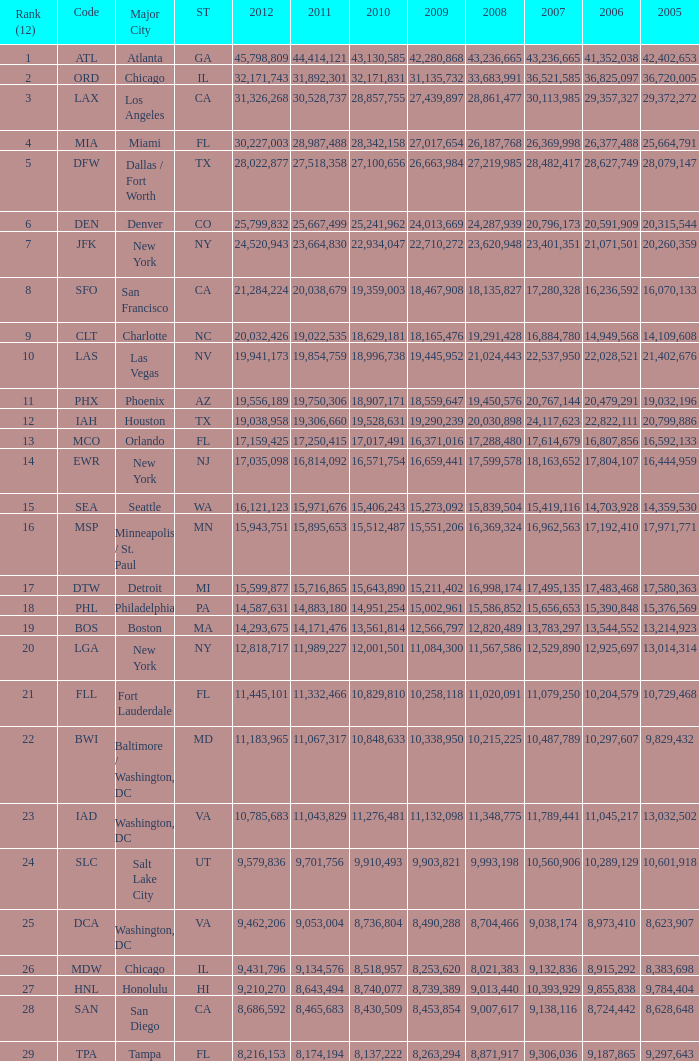Could you parse the entire table? {'header': ['Rank (12)', 'Code', 'Major City', 'ST', '2012', '2011', '2010', '2009', '2008', '2007', '2006', '2005'], 'rows': [['1', 'ATL', 'Atlanta', 'GA', '45,798,809', '44,414,121', '43,130,585', '42,280,868', '43,236,665', '43,236,665', '41,352,038', '42,402,653'], ['2', 'ORD', 'Chicago', 'IL', '32,171,743', '31,892,301', '32,171,831', '31,135,732', '33,683,991', '36,521,585', '36,825,097', '36,720,005'], ['3', 'LAX', 'Los Angeles', 'CA', '31,326,268', '30,528,737', '28,857,755', '27,439,897', '28,861,477', '30,113,985', '29,357,327', '29,372,272'], ['4', 'MIA', 'Miami', 'FL', '30,227,003', '28,987,488', '28,342,158', '27,017,654', '26,187,768', '26,369,998', '26,377,488', '25,664,791'], ['5', 'DFW', 'Dallas / Fort Worth', 'TX', '28,022,877', '27,518,358', '27,100,656', '26,663,984', '27,219,985', '28,482,417', '28,627,749', '28,079,147'], ['6', 'DEN', 'Denver', 'CO', '25,799,832', '25,667,499', '25,241,962', '24,013,669', '24,287,939', '20,796,173', '20,591,909', '20,315,544'], ['7', 'JFK', 'New York', 'NY', '24,520,943', '23,664,830', '22,934,047', '22,710,272', '23,620,948', '23,401,351', '21,071,501', '20,260,359'], ['8', 'SFO', 'San Francisco', 'CA', '21,284,224', '20,038,679', '19,359,003', '18,467,908', '18,135,827', '17,280,328', '16,236,592', '16,070,133'], ['9', 'CLT', 'Charlotte', 'NC', '20,032,426', '19,022,535', '18,629,181', '18,165,476', '19,291,428', '16,884,780', '14,949,568', '14,109,608'], ['10', 'LAS', 'Las Vegas', 'NV', '19,941,173', '19,854,759', '18,996,738', '19,445,952', '21,024,443', '22,537,950', '22,028,521', '21,402,676'], ['11', 'PHX', 'Phoenix', 'AZ', '19,556,189', '19,750,306', '18,907,171', '18,559,647', '19,450,576', '20,767,144', '20,479,291', '19,032,196'], ['12', 'IAH', 'Houston', 'TX', '19,038,958', '19,306,660', '19,528,631', '19,290,239', '20,030,898', '24,117,623', '22,822,111', '20,799,886'], ['13', 'MCO', 'Orlando', 'FL', '17,159,425', '17,250,415', '17,017,491', '16,371,016', '17,288,480', '17,614,679', '16,807,856', '16,592,133'], ['14', 'EWR', 'New York', 'NJ', '17,035,098', '16,814,092', '16,571,754', '16,659,441', '17,599,578', '18,163,652', '17,804,107', '16,444,959'], ['15', 'SEA', 'Seattle', 'WA', '16,121,123', '15,971,676', '15,406,243', '15,273,092', '15,839,504', '15,419,116', '14,703,928', '14,359,530'], ['16', 'MSP', 'Minneapolis / St. Paul', 'MN', '15,943,751', '15,895,653', '15,512,487', '15,551,206', '16,369,324', '16,962,563', '17,192,410', '17,971,771'], ['17', 'DTW', 'Detroit', 'MI', '15,599,877', '15,716,865', '15,643,890', '15,211,402', '16,998,174', '17,495,135', '17,483,468', '17,580,363'], ['18', 'PHL', 'Philadelphia', 'PA', '14,587,631', '14,883,180', '14,951,254', '15,002,961', '15,586,852', '15,656,653', '15,390,848', '15,376,569'], ['19', 'BOS', 'Boston', 'MA', '14,293,675', '14,171,476', '13,561,814', '12,566,797', '12,820,489', '13,783,297', '13,544,552', '13,214,923'], ['20', 'LGA', 'New York', 'NY', '12,818,717', '11,989,227', '12,001,501', '11,084,300', '11,567,586', '12,529,890', '12,925,697', '13,014,314'], ['21', 'FLL', 'Fort Lauderdale', 'FL', '11,445,101', '11,332,466', '10,829,810', '10,258,118', '11,020,091', '11,079,250', '10,204,579', '10,729,468'], ['22', 'BWI', 'Baltimore / Washington, DC', 'MD', '11,183,965', '11,067,317', '10,848,633', '10,338,950', '10,215,225', '10,487,789', '10,297,607', '9,829,432'], ['23', 'IAD', 'Washington, DC', 'VA', '10,785,683', '11,043,829', '11,276,481', '11,132,098', '11,348,775', '11,789,441', '11,045,217', '13,032,502'], ['24', 'SLC', 'Salt Lake City', 'UT', '9,579,836', '9,701,756', '9,910,493', '9,903,821', '9,993,198', '10,560,906', '10,289,129', '10,601,918'], ['25', 'DCA', 'Washington, DC', 'VA', '9,462,206', '9,053,004', '8,736,804', '8,490,288', '8,704,466', '9,038,174', '8,973,410', '8,623,907'], ['26', 'MDW', 'Chicago', 'IL', '9,431,796', '9,134,576', '8,518,957', '8,253,620', '8,021,383', '9,132,836', '8,915,292', '8,383,698'], ['27', 'HNL', 'Honolulu', 'HI', '9,210,270', '8,643,494', '8,740,077', '8,739,389', '9,013,440', '10,393,929', '9,855,838', '9,784,404'], ['28', 'SAN', 'San Diego', 'CA', '8,686,592', '8,465,683', '8,430,509', '8,453,854', '9,007,617', '9,138,116', '8,724,442', '8,628,648'], ['29', 'TPA', 'Tampa', 'FL', '8,216,153', '8,174,194', '8,137,222', '8,263,294', '8,871,917', '9,306,036', '9,187,865', '9,297,643']]} When Philadelphia has a 2007 less than 20,796,173 and a 2008 more than 10,215,225, what is the smallest 2009? 15002961.0. 